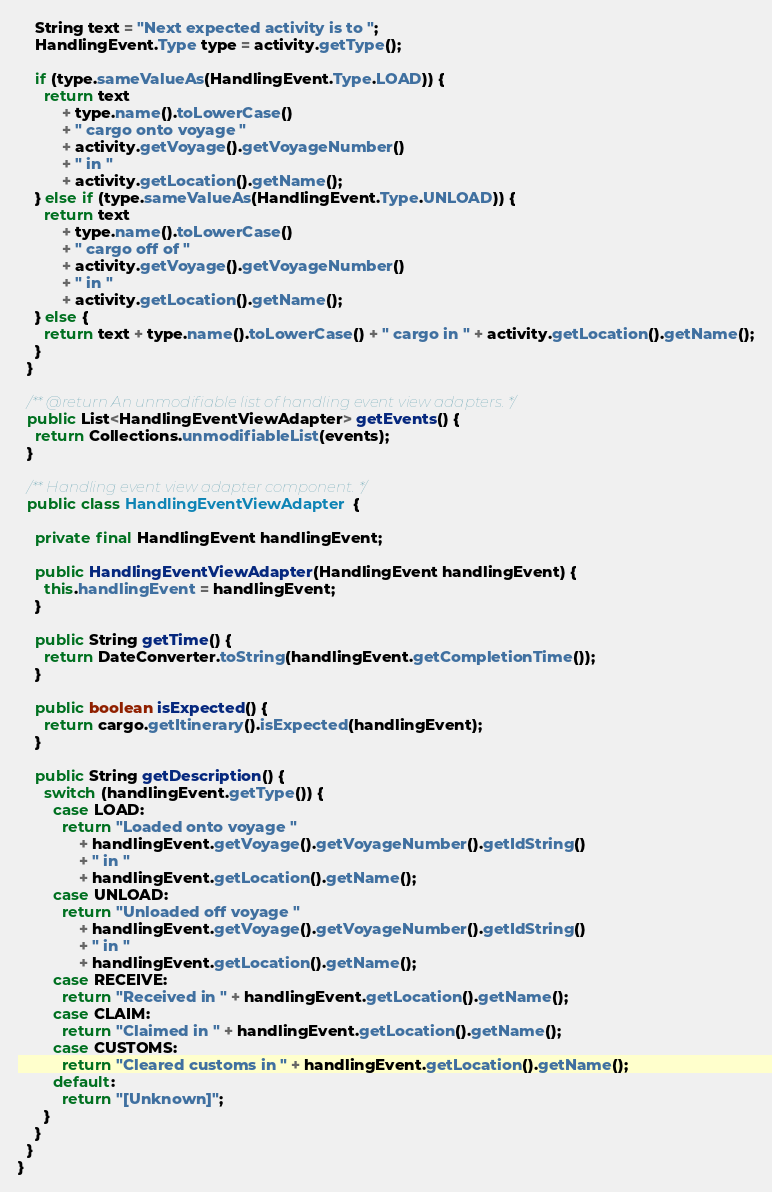<code> <loc_0><loc_0><loc_500><loc_500><_Java_>    String text = "Next expected activity is to ";
    HandlingEvent.Type type = activity.getType();

    if (type.sameValueAs(HandlingEvent.Type.LOAD)) {
      return text
          + type.name().toLowerCase()
          + " cargo onto voyage "
          + activity.getVoyage().getVoyageNumber()
          + " in "
          + activity.getLocation().getName();
    } else if (type.sameValueAs(HandlingEvent.Type.UNLOAD)) {
      return text
          + type.name().toLowerCase()
          + " cargo off of "
          + activity.getVoyage().getVoyageNumber()
          + " in "
          + activity.getLocation().getName();
    } else {
      return text + type.name().toLowerCase() + " cargo in " + activity.getLocation().getName();
    }
  }

  /** @return An unmodifiable list of handling event view adapters. */
  public List<HandlingEventViewAdapter> getEvents() {
    return Collections.unmodifiableList(events);
  }

  /** Handling event view adapter component. */
  public class HandlingEventViewAdapter {

    private final HandlingEvent handlingEvent;

    public HandlingEventViewAdapter(HandlingEvent handlingEvent) {
      this.handlingEvent = handlingEvent;
    }

    public String getTime() {
      return DateConverter.toString(handlingEvent.getCompletionTime());
    }

    public boolean isExpected() {
      return cargo.getItinerary().isExpected(handlingEvent);
    }

    public String getDescription() {
      switch (handlingEvent.getType()) {
        case LOAD:
          return "Loaded onto voyage "
              + handlingEvent.getVoyage().getVoyageNumber().getIdString()
              + " in "
              + handlingEvent.getLocation().getName();
        case UNLOAD:
          return "Unloaded off voyage "
              + handlingEvent.getVoyage().getVoyageNumber().getIdString()
              + " in "
              + handlingEvent.getLocation().getName();
        case RECEIVE:
          return "Received in " + handlingEvent.getLocation().getName();
        case CLAIM:
          return "Claimed in " + handlingEvent.getLocation().getName();
        case CUSTOMS:
          return "Cleared customs in " + handlingEvent.getLocation().getName();
        default:
          return "[Unknown]";
      }
    }
  }
}
</code> 